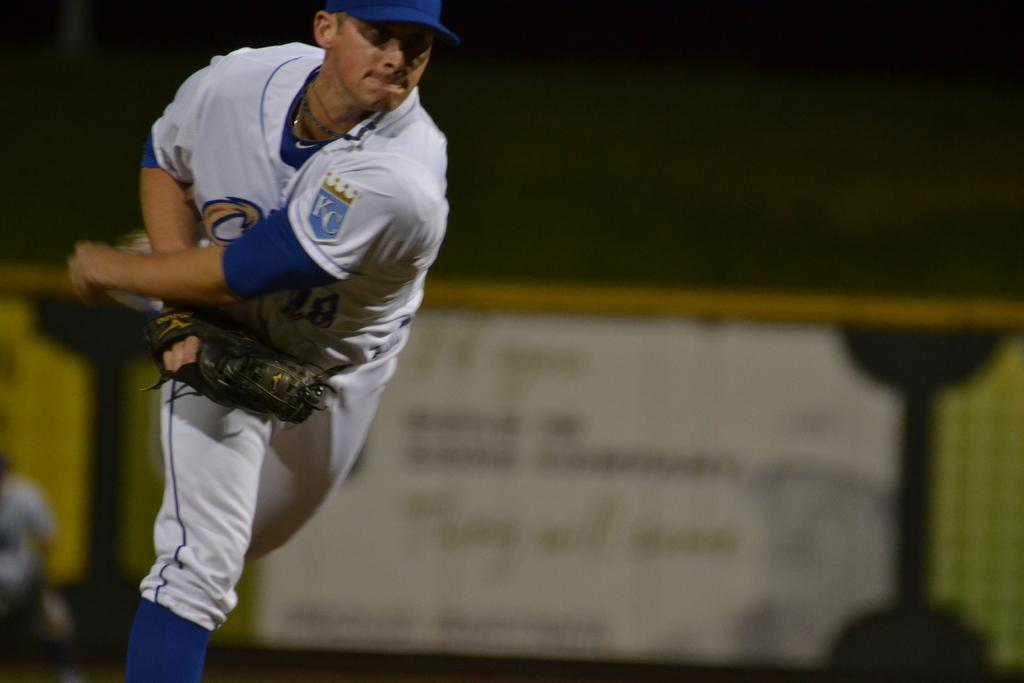What team does he play for?
Your answer should be very brief. Unanswerable. 